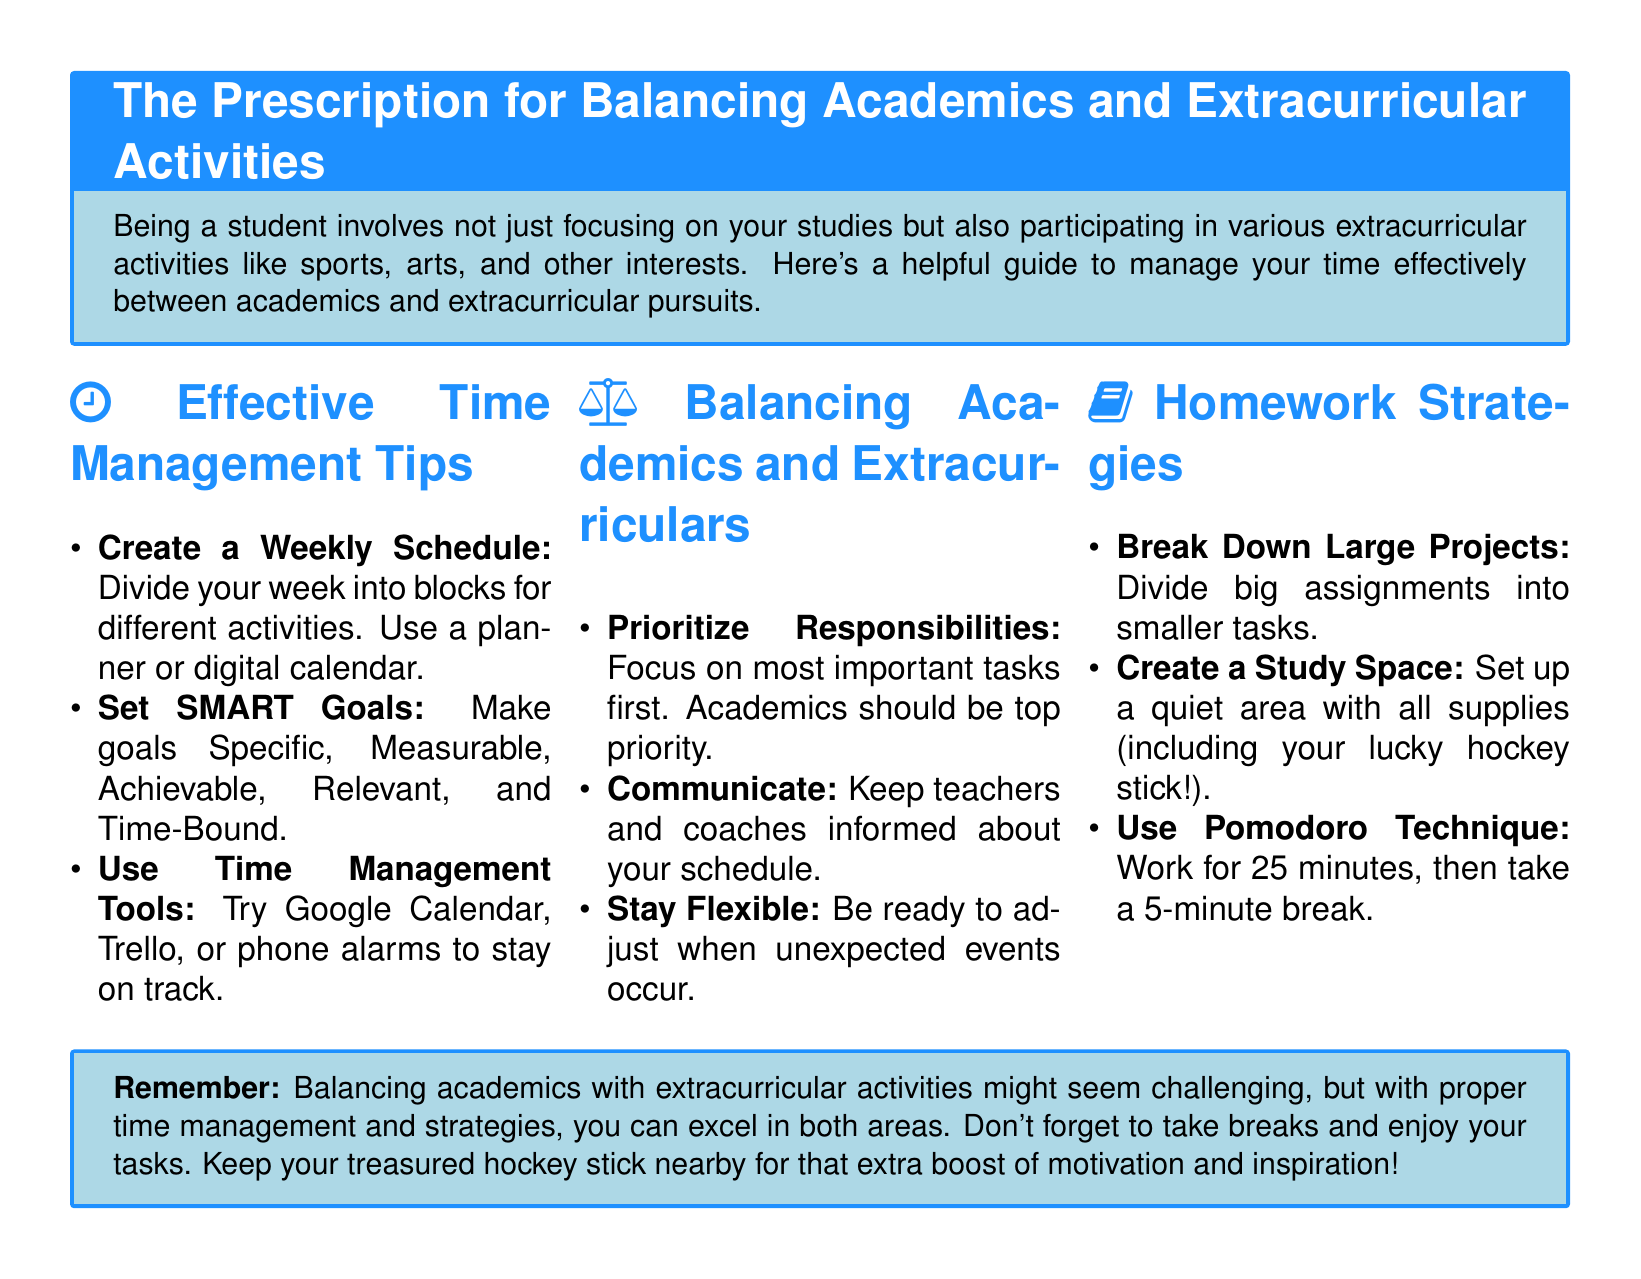what is the title of the document? The title of the document is stated at the beginning as "The Prescription for Balancing Academics and Extracurricular Activities."
Answer: The Prescription for Balancing Academics and Extracurricular Activities how many sections are in the document? The document includes three sections: Effective Time Management Tips, Balancing Academics and Extracurriculars, and Homework Strategies.
Answer: Three what does SMART stand for? SMART is an acronym for Specific, Measurable, Achievable, Relevant, and Time-Bound, which is mentioned in the Effective Time Management Tips section.
Answer: Specific, Measurable, Achievable, Relevant, Time-Bound what technique is suggested for studying? The document suggests the Pomodoro Technique in the Homework Strategies section.
Answer: Pomodoro Technique what is one recommended time management tool? The document lists Google Calendar as an example of a time management tool.
Answer: Google Calendar what should be prioritized according to the document? The document advises that academics should be the top priority when balancing responsibilities.
Answer: Academics how long should you work before taking a break using the Pomodoro Technique? The Pomodoro Technique recommends working for 25 minutes before taking a break.
Answer: 25 minutes what should you do with large projects according to the homework strategies? The document recommends breaking down large projects into smaller tasks.
Answer: Break down large projects what is a suggested feature for a study space? The document suggests setting up a quiet area with all supplies for your study space.
Answer: Quiet area with all supplies 